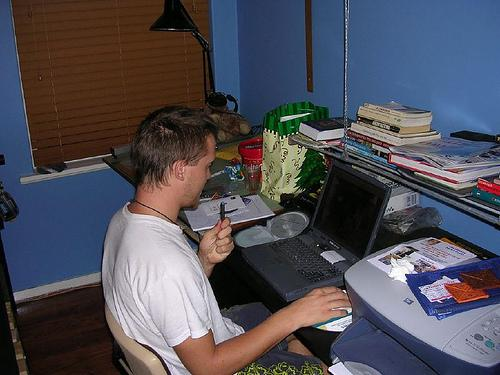What is he doing?

Choices:
A) eating fruit
B) playing game
C) recording voice
D) testing mouse recording voice 